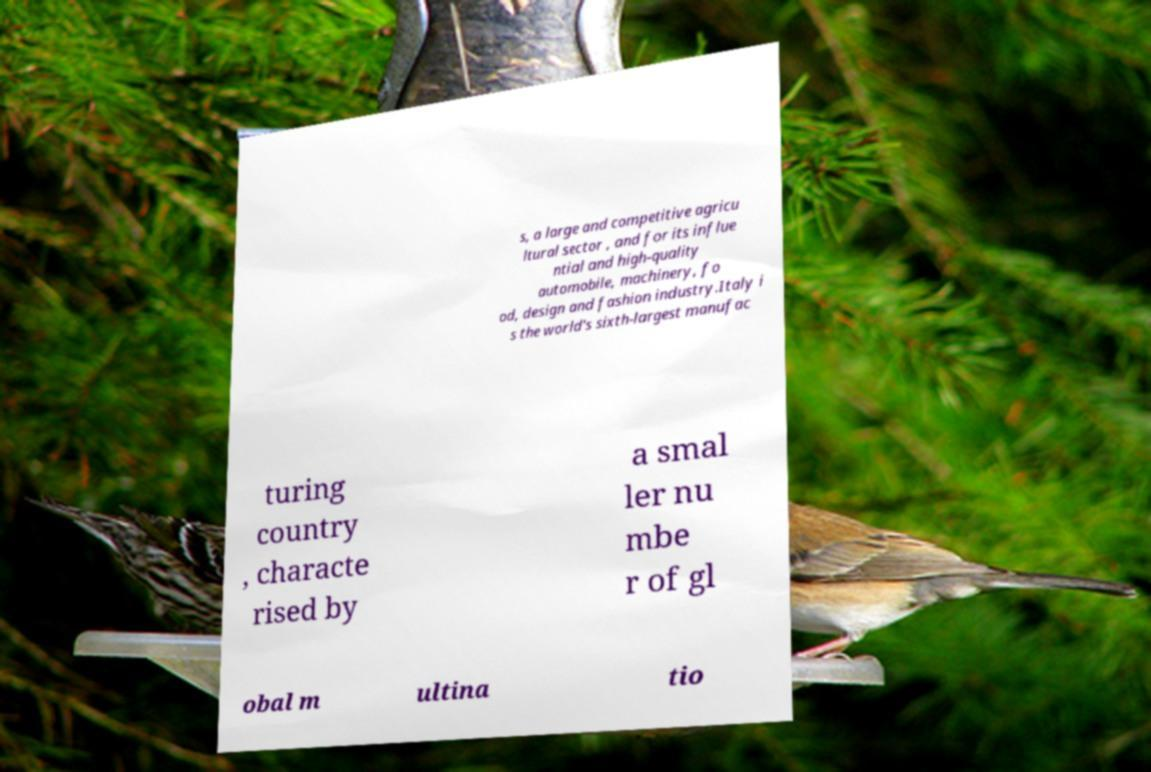Can you read and provide the text displayed in the image?This photo seems to have some interesting text. Can you extract and type it out for me? s, a large and competitive agricu ltural sector , and for its influe ntial and high-quality automobile, machinery, fo od, design and fashion industry.Italy i s the world's sixth-largest manufac turing country , characte rised by a smal ler nu mbe r of gl obal m ultina tio 